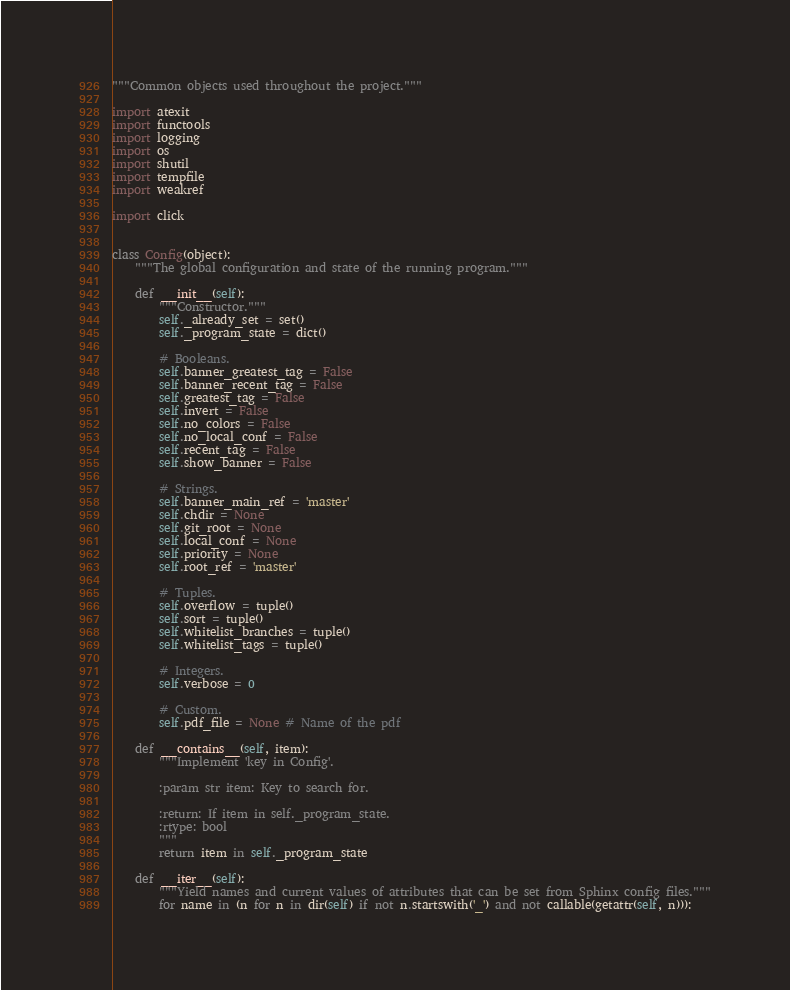Convert code to text. <code><loc_0><loc_0><loc_500><loc_500><_Python_>"""Common objects used throughout the project."""

import atexit
import functools
import logging
import os
import shutil
import tempfile
import weakref

import click


class Config(object):
    """The global configuration and state of the running program."""

    def __init__(self):
        """Constructor."""
        self._already_set = set()
        self._program_state = dict()

        # Booleans.
        self.banner_greatest_tag = False
        self.banner_recent_tag = False
        self.greatest_tag = False
        self.invert = False
        self.no_colors = False
        self.no_local_conf = False
        self.recent_tag = False
        self.show_banner = False

        # Strings.
        self.banner_main_ref = 'master'
        self.chdir = None
        self.git_root = None
        self.local_conf = None
        self.priority = None
        self.root_ref = 'master'

        # Tuples.
        self.overflow = tuple()
        self.sort = tuple()
        self.whitelist_branches = tuple()
        self.whitelist_tags = tuple()

        # Integers.
        self.verbose = 0

        # Custom.
        self.pdf_file = None # Name of the pdf

    def __contains__(self, item):
        """Implement 'key in Config'.

        :param str item: Key to search for.

        :return: If item in self._program_state.
        :rtype: bool
        """
        return item in self._program_state

    def __iter__(self):
        """Yield names and current values of attributes that can be set from Sphinx config files."""
        for name in (n for n in dir(self) if not n.startswith('_') and not callable(getattr(self, n))):</code> 